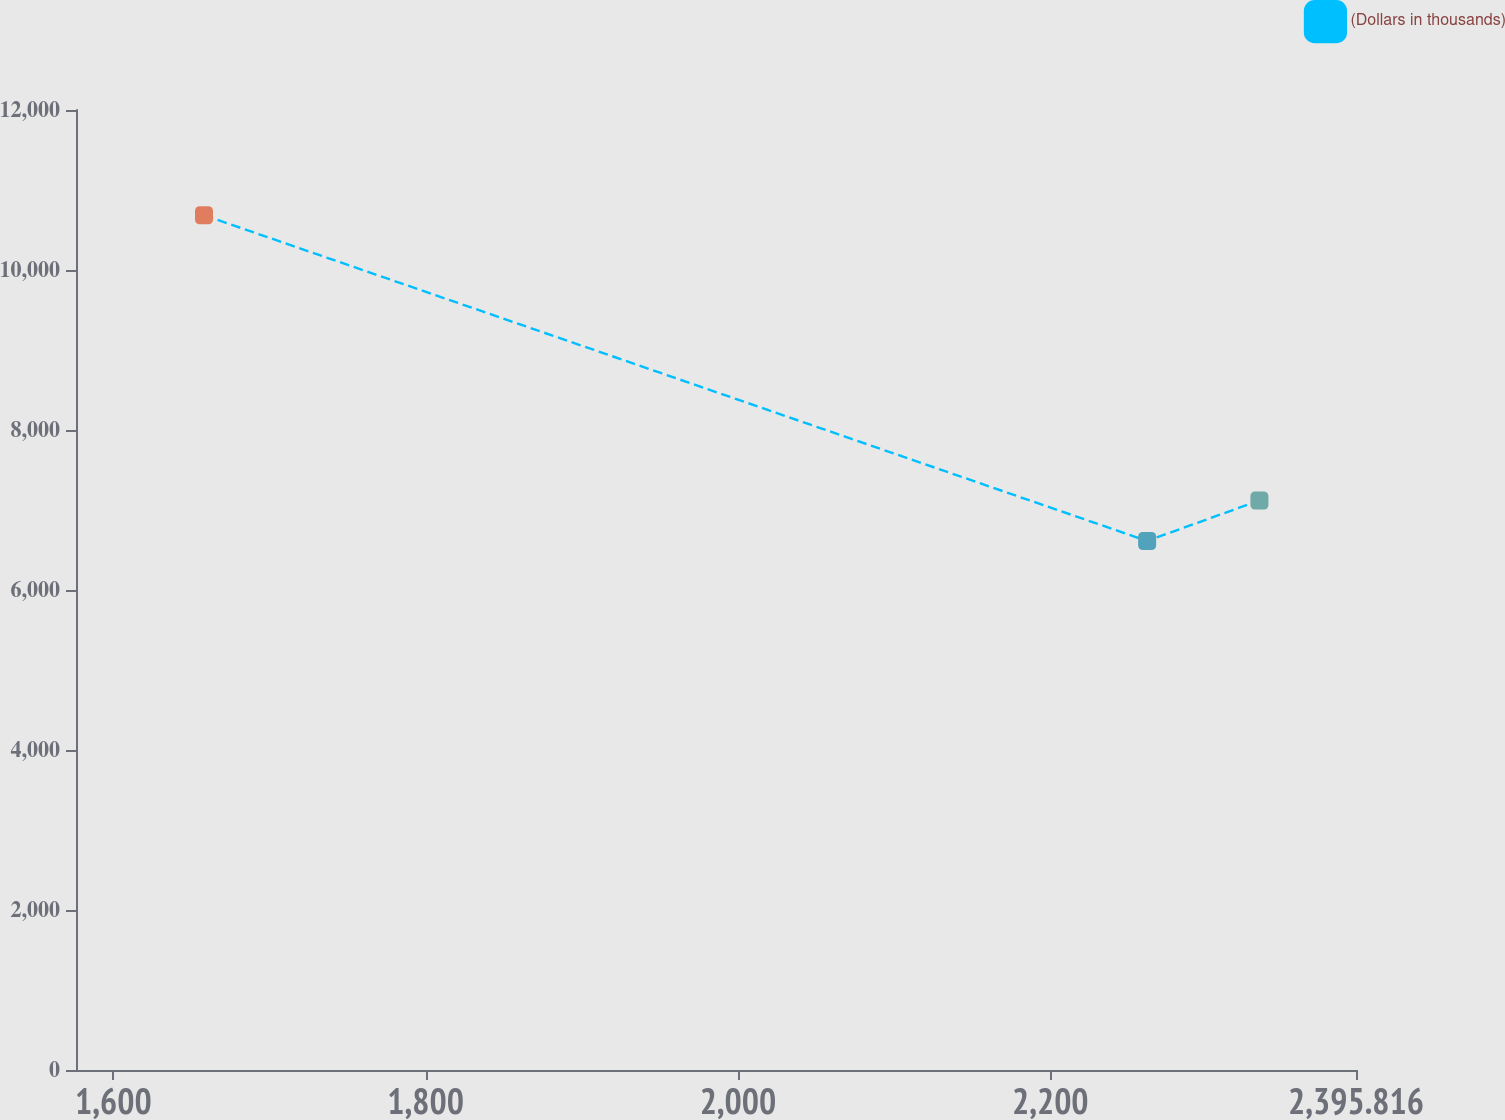Convert chart. <chart><loc_0><loc_0><loc_500><loc_500><line_chart><ecel><fcel>(Dollars in thousands)<nl><fcel>1658.05<fcel>10684.7<nl><fcel>2262.06<fcel>6613.09<nl><fcel>2333.97<fcel>7119.33<nl><fcel>2405.88<fcel>9285.26<nl><fcel>2477.79<fcel>11675.5<nl></chart> 